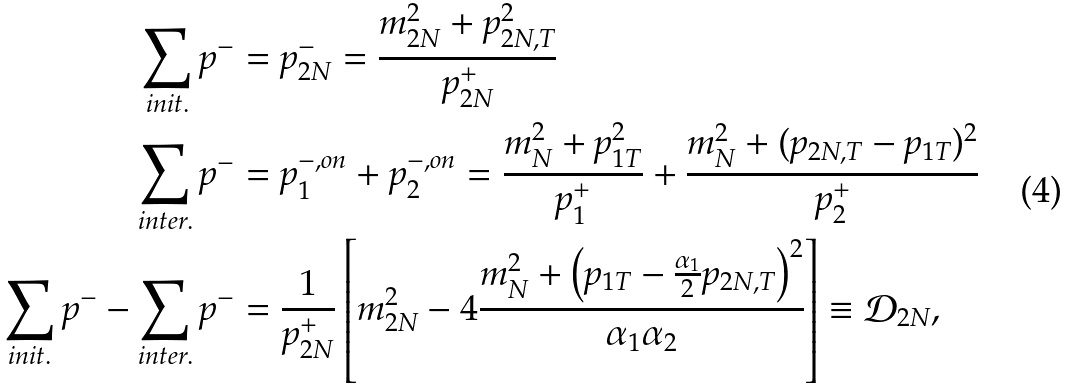Convert formula to latex. <formula><loc_0><loc_0><loc_500><loc_500>\sum _ { i n i t . } p ^ { - } & = p _ { 2 N } ^ { - } = \frac { m _ { 2 N } ^ { 2 } + p _ { 2 N , T } ^ { 2 } } { p _ { 2 N } ^ { + } } \\ \sum _ { i n t e r . } p ^ { - } & = p _ { 1 } ^ { - , o n } + p _ { 2 } ^ { - , o n } = \frac { m _ { N } ^ { 2 } + p _ { 1 T } ^ { 2 } } { p _ { 1 } ^ { + } } + \frac { m _ { N } ^ { 2 } + ( p _ { 2 N , T } - p _ { 1 T } ) ^ { 2 } } { p _ { 2 } ^ { + } } \\ \sum _ { i n i t . } p ^ { - } - \sum _ { i n t e r . } p ^ { - } & = \frac { 1 } { p _ { 2 N } ^ { + } } \left [ m _ { 2 N } ^ { 2 } - 4 \frac { m _ { N } ^ { 2 } + \left ( p _ { 1 T } - \frac { \alpha _ { 1 } } { 2 } p _ { 2 N , T } \right ) ^ { 2 } } { \alpha _ { 1 } \alpha _ { 2 } } \right ] \equiv \mathcal { D } _ { 2 N } ,</formula> 